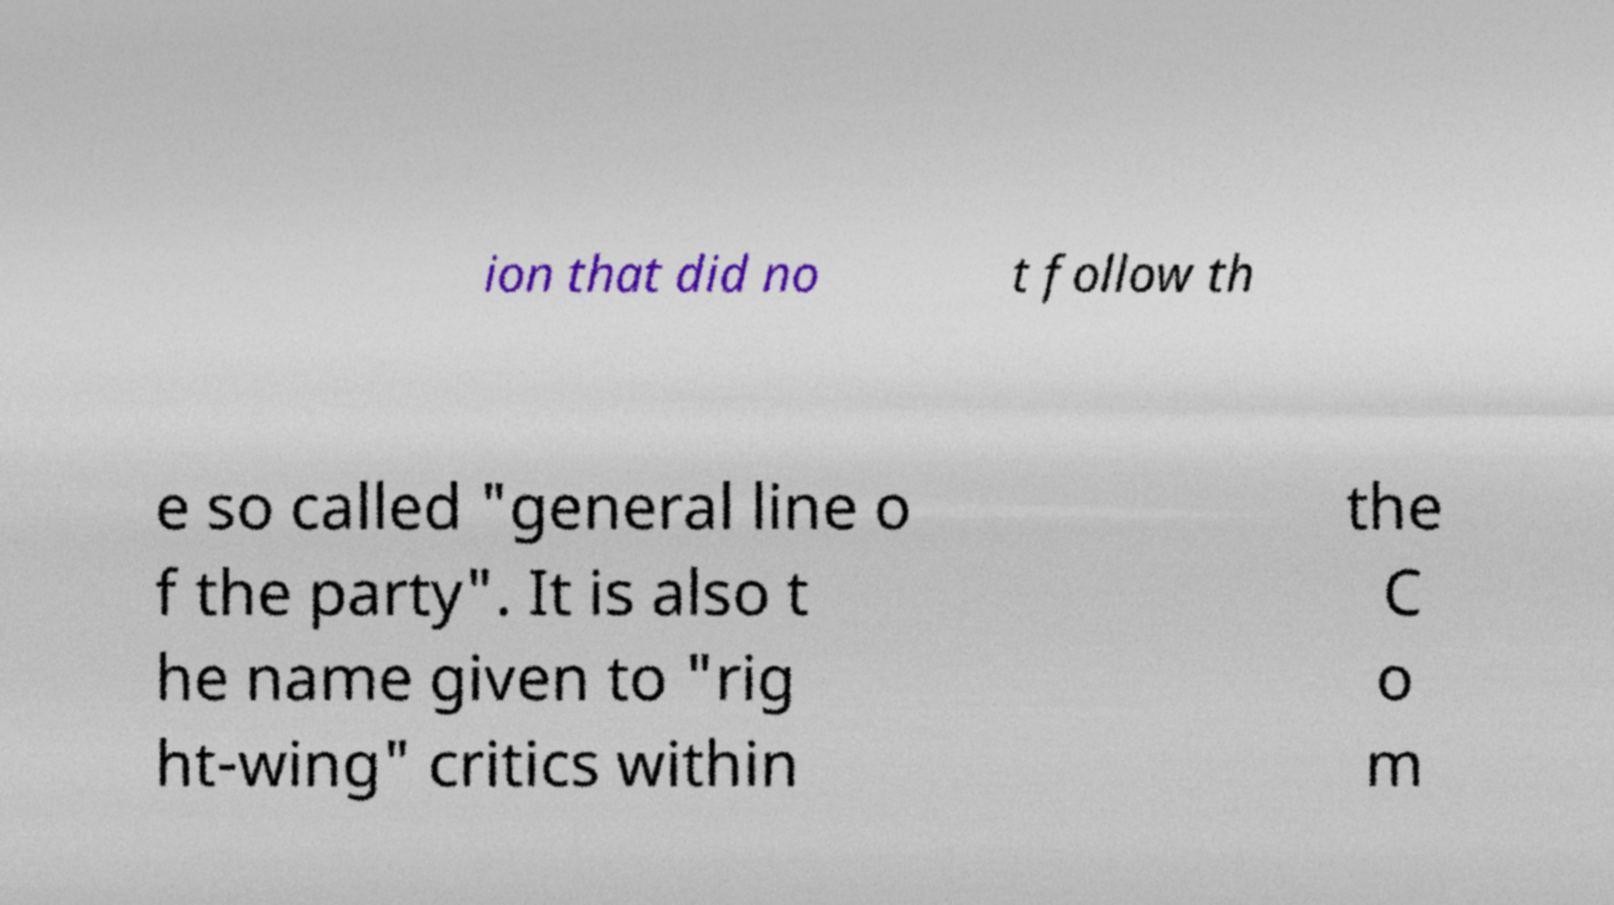Could you assist in decoding the text presented in this image and type it out clearly? ion that did no t follow th e so called "general line o f the party". It is also t he name given to "rig ht-wing" critics within the C o m 